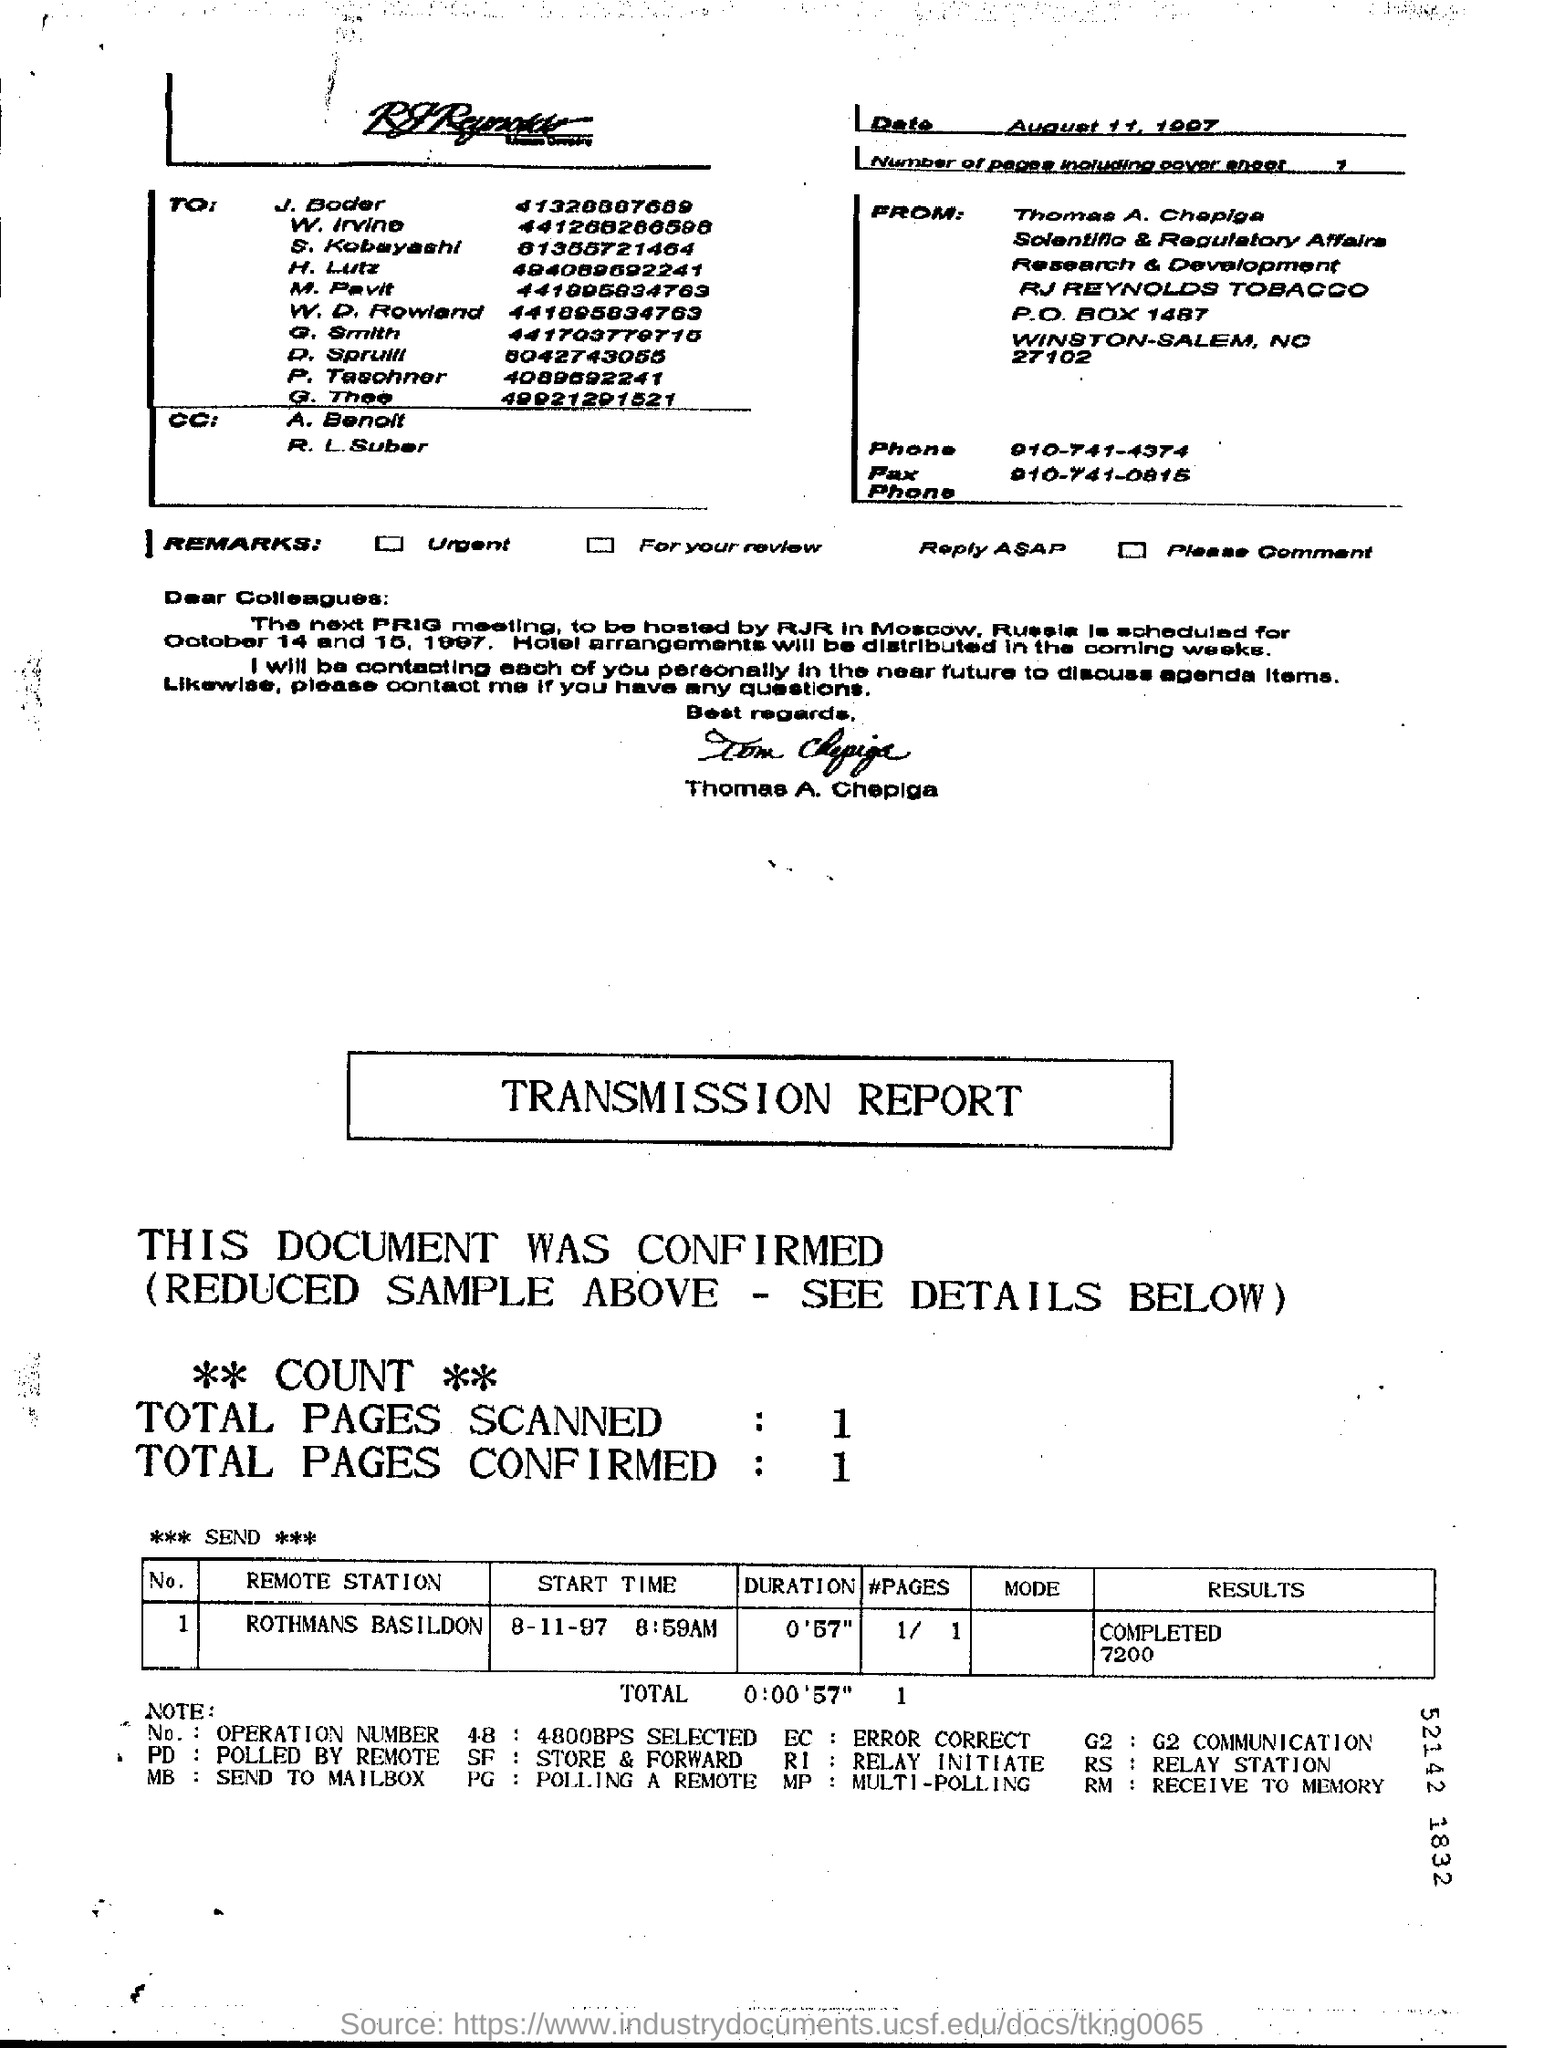Next PRG Meeting  is scheduled for which date?
Ensure brevity in your answer.  October 14 and 15. 